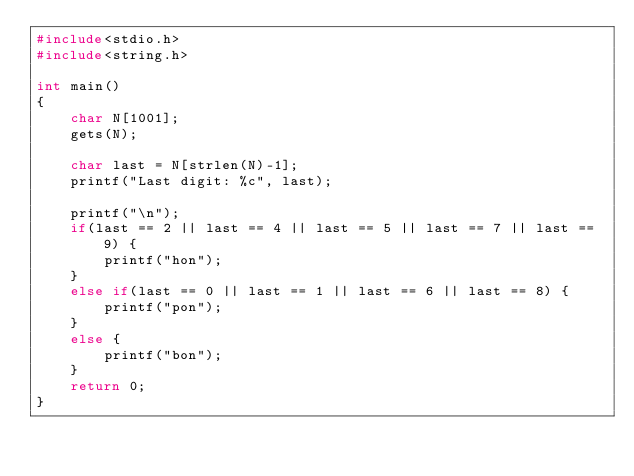<code> <loc_0><loc_0><loc_500><loc_500><_C_>#include<stdio.h>
#include<string.h>

int main()
{
    char N[1001];
    gets(N);

    char last = N[strlen(N)-1];
    printf("Last digit: %c", last);

    printf("\n");
    if(last == 2 || last == 4 || last == 5 || last == 7 || last == 9) {
        printf("hon");
    }
    else if(last == 0 || last == 1 || last == 6 || last == 8) {
        printf("pon");
    }
    else {
        printf("bon");
    }
    return 0;
}
</code> 